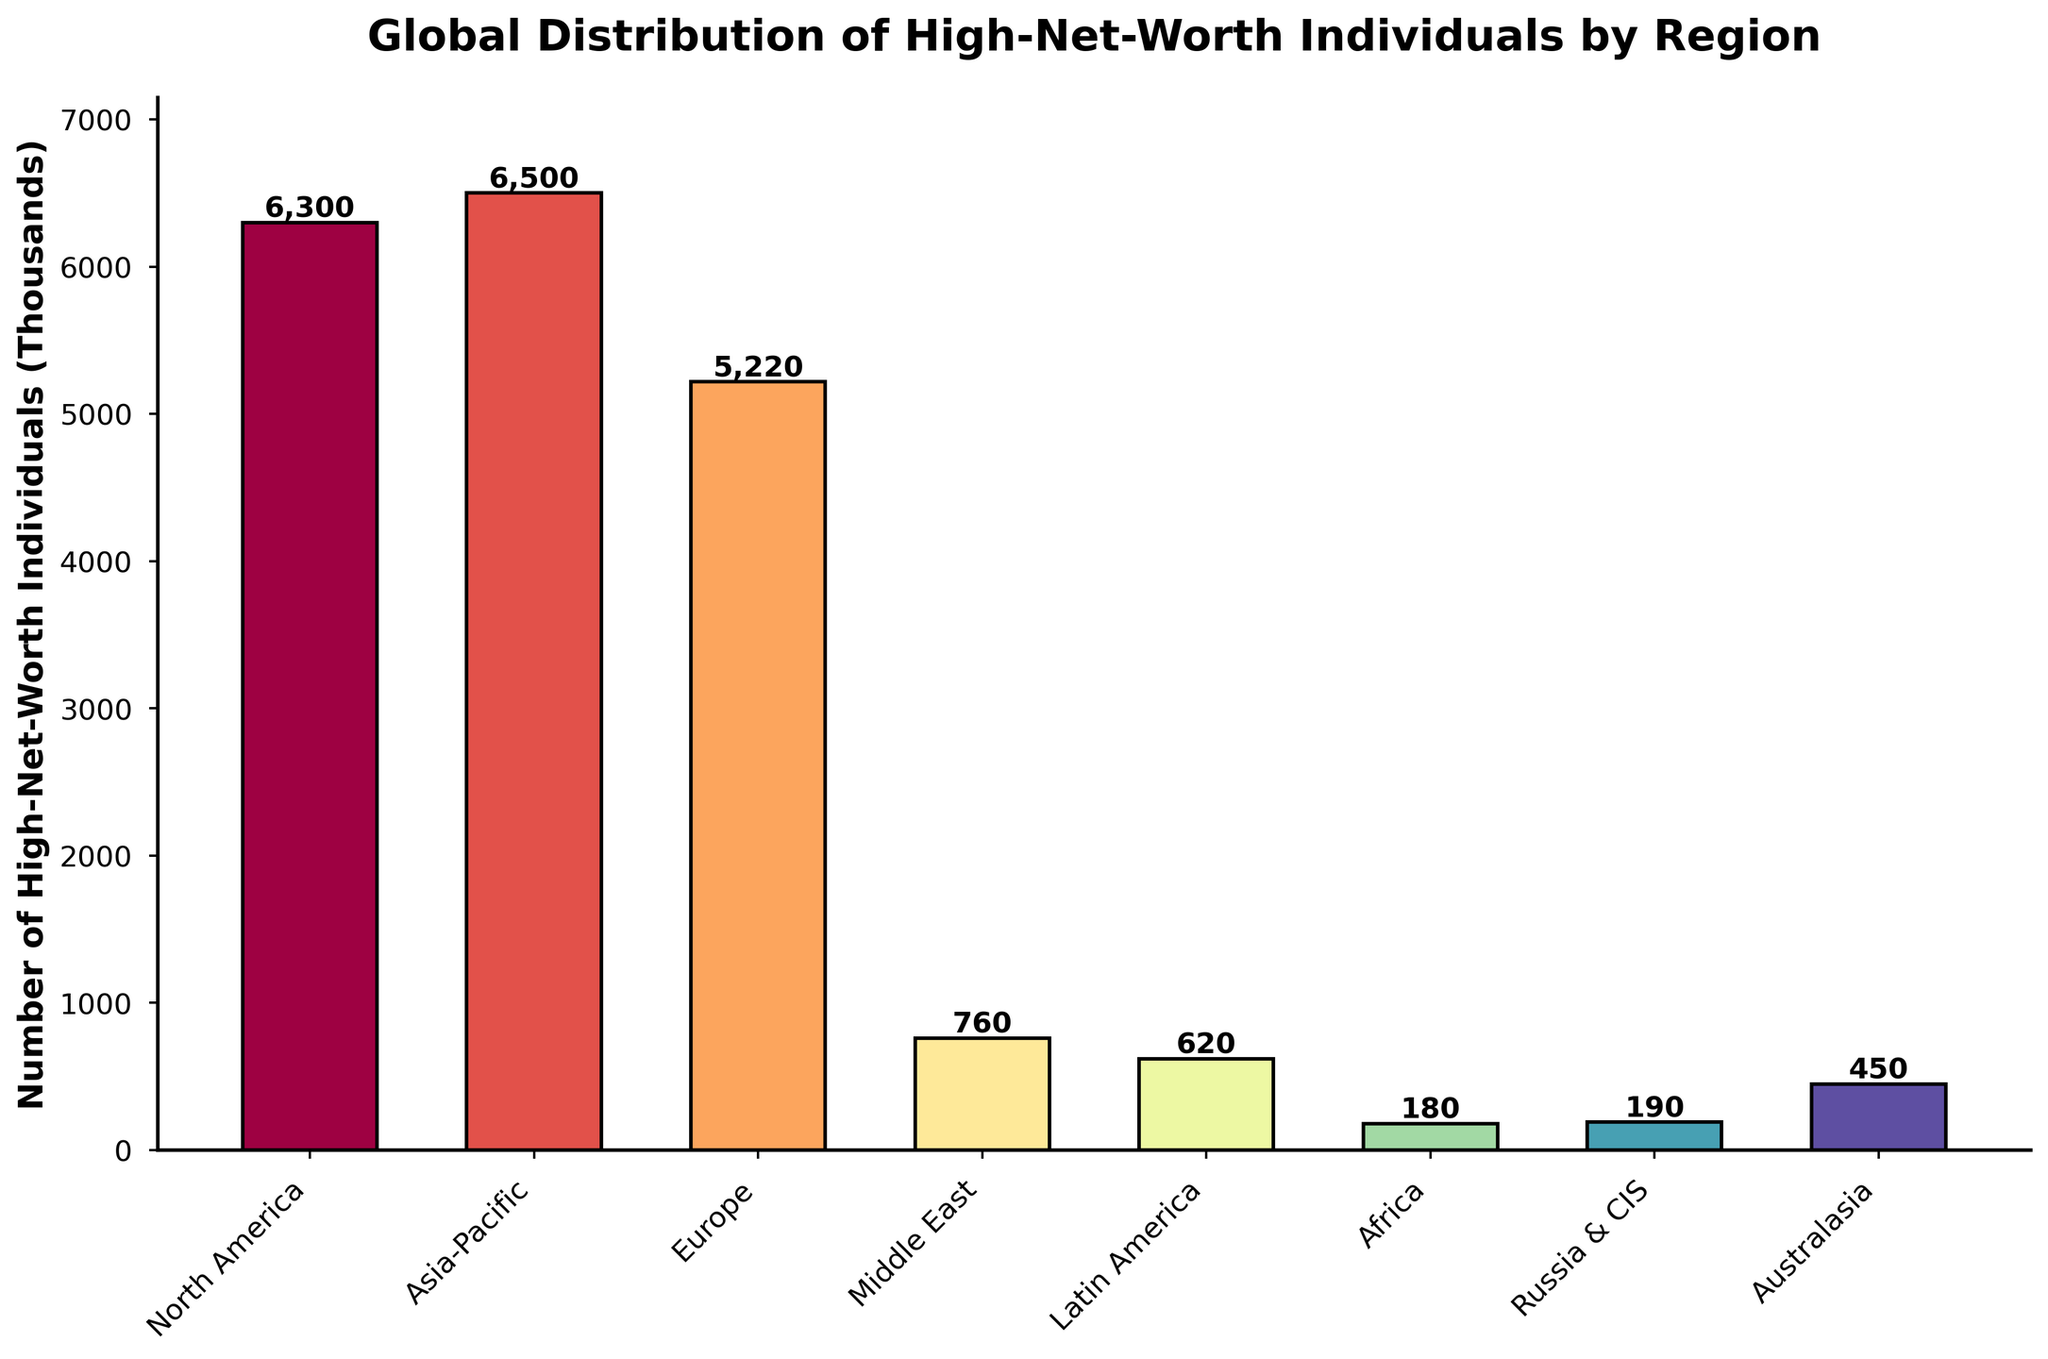Which region has the highest number of high-net-worth individuals? By observing the heights of the bars, the Asia-Pacific region has the tallest bar, indicating the highest number of high-net-worth individuals.
Answer: Asia-Pacific Which region has the lowest number of high-net-worth individuals? By observing the heights of the bars, the Africa region has the shortest bar, indicating the lowest number of high-net-worth individuals.
Answer: Africa What is the total number of high-net-worth individuals in North America and Europe combined? The number of high-net-worth individuals in North America is 6300 (thousands) and in Europe is 5220 (thousands). Combining them gives 6300 + 5220 = 11520.
Answer: 11520 How much greater is the number of high-net-worth individuals in Asia-Pacific compared to Latin America? The number of high-net-worth individuals in Asia-Pacific is 6500 (thousands) and in Latin America is 620 (thousands). The difference is 6500 - 620 = 5880.
Answer: 5880 Which region has a slightly greater number of high-net-worth individuals, Middle East or Latin America? By comparing the heights of the bars for Middle East (760) and Latin America (620), the Middle East has slightly more high-net-worth individuals.
Answer: Middle East Arrange the regions in descending order of high-net-worth individuals. Observing the heights of the bars, descending order is: Asia-Pacific, North America, Europe, Middle East, Latin America, Australasia, Russia & CIS, Africa.
Answer: Asia-Pacific, North America, Europe, Middle East, Latin America, Australasia, Russia & CIS, Africa By how much do the high-net-worth individuals in Europe exceed those in the Middle East? The number of high-net-worth individuals in Europe is 5220 (thousands) and in Middle East is 760 (thousands). The difference is 5220 - 760 = 4460.
Answer: 4460 What is the combined number of high-net-worth individuals in the regions excluding North America and Asia-Pacific? The total excluding North America (6300) and Asia-Pacific (6500) is found by summing the remaining regions: Europe (5220) + Middle East (760) + Latin America (620) + Africa (180) + Russia & CIS (190) + Australasia (450) = 7420.
Answer: 7420 